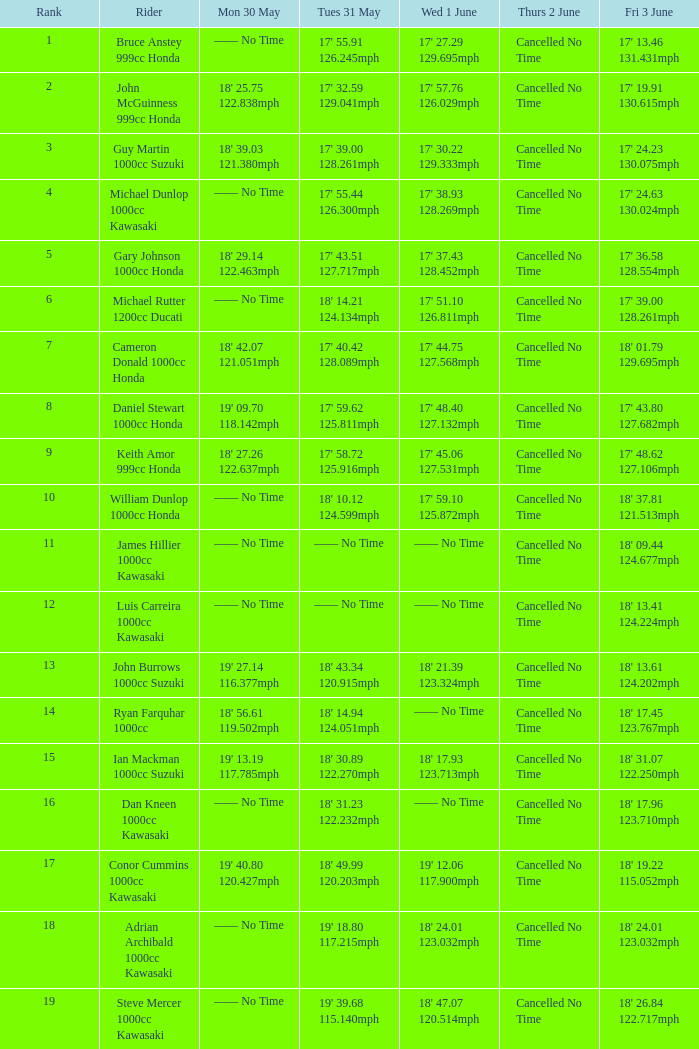For a rider with a time of 17 minutes, 36.58 seconds and 128.554 mph on friday, june 3, what was their time on thursday, june 2? Cancelled No Time. Would you mind parsing the complete table? {'header': ['Rank', 'Rider', 'Mon 30 May', 'Tues 31 May', 'Wed 1 June', 'Thurs 2 June', 'Fri 3 June'], 'rows': [['1', 'Bruce Anstey 999cc Honda', '—— No Time', "17' 55.91 126.245mph", "17' 27.29 129.695mph", 'Cancelled No Time', "17' 13.46 131.431mph"], ['2', 'John McGuinness 999cc Honda', "18' 25.75 122.838mph", "17' 32.59 129.041mph", "17' 57.76 126.029mph", 'Cancelled No Time', "17' 19.91 130.615mph"], ['3', 'Guy Martin 1000cc Suzuki', "18' 39.03 121.380mph", "17' 39.00 128.261mph", "17' 30.22 129.333mph", 'Cancelled No Time', "17' 24.23 130.075mph"], ['4', 'Michael Dunlop 1000cc Kawasaki', '—— No Time', "17' 55.44 126.300mph", "17' 38.93 128.269mph", 'Cancelled No Time', "17' 24.63 130.024mph"], ['5', 'Gary Johnson 1000cc Honda', "18' 29.14 122.463mph", "17' 43.51 127.717mph", "17' 37.43 128.452mph", 'Cancelled No Time', "17' 36.58 128.554mph"], ['6', 'Michael Rutter 1200cc Ducati', '—— No Time', "18' 14.21 124.134mph", "17' 51.10 126.811mph", 'Cancelled No Time', "17' 39.00 128.261mph"], ['7', 'Cameron Donald 1000cc Honda', "18' 42.07 121.051mph", "17' 40.42 128.089mph", "17' 44.75 127.568mph", 'Cancelled No Time', "18' 01.79 129.695mph"], ['8', 'Daniel Stewart 1000cc Honda', "19' 09.70 118.142mph", "17' 59.62 125.811mph", "17' 48.40 127.132mph", 'Cancelled No Time', "17' 43.80 127.682mph"], ['9', 'Keith Amor 999cc Honda', "18' 27.26 122.637mph", "17' 58.72 125.916mph", "17' 45.06 127.531mph", 'Cancelled No Time', "17' 48.62 127.106mph"], ['10', 'William Dunlop 1000cc Honda', '—— No Time', "18' 10.12 124.599mph", "17' 59.10 125.872mph", 'Cancelled No Time', "18' 37.81 121.513mph"], ['11', 'James Hillier 1000cc Kawasaki', '—— No Time', '—— No Time', '—— No Time', 'Cancelled No Time', "18' 09.44 124.677mph"], ['12', 'Luis Carreira 1000cc Kawasaki', '—— No Time', '—— No Time', '—— No Time', 'Cancelled No Time', "18' 13.41 124.224mph"], ['13', 'John Burrows 1000cc Suzuki', "19' 27.14 116.377mph", "18' 43.34 120.915mph", "18' 21.39 123.324mph", 'Cancelled No Time', "18' 13.61 124.202mph"], ['14', 'Ryan Farquhar 1000cc', "18' 56.61 119.502mph", "18' 14.94 124.051mph", '—— No Time', 'Cancelled No Time', "18' 17.45 123.767mph"], ['15', 'Ian Mackman 1000cc Suzuki', "19' 13.19 117.785mph", "18' 30.89 122.270mph", "18' 17.93 123.713mph", 'Cancelled No Time', "18' 31.07 122.250mph"], ['16', 'Dan Kneen 1000cc Kawasaki', '—— No Time', "18' 31.23 122.232mph", '—— No Time', 'Cancelled No Time', "18' 17.96 123.710mph"], ['17', 'Conor Cummins 1000cc Kawasaki', "19' 40.80 120.427mph", "18' 49.99 120.203mph", "19' 12.06 117.900mph", 'Cancelled No Time', "18' 19.22 115.052mph"], ['18', 'Adrian Archibald 1000cc Kawasaki', '—— No Time', "19' 18.80 117.215mph", "18' 24.01 123.032mph", 'Cancelled No Time', "18' 24.01 123.032mph"], ['19', 'Steve Mercer 1000cc Kawasaki', '—— No Time', "19' 39.68 115.140mph", "18' 47.07 120.514mph", 'Cancelled No Time', "18' 26.84 122.717mph"]]} 